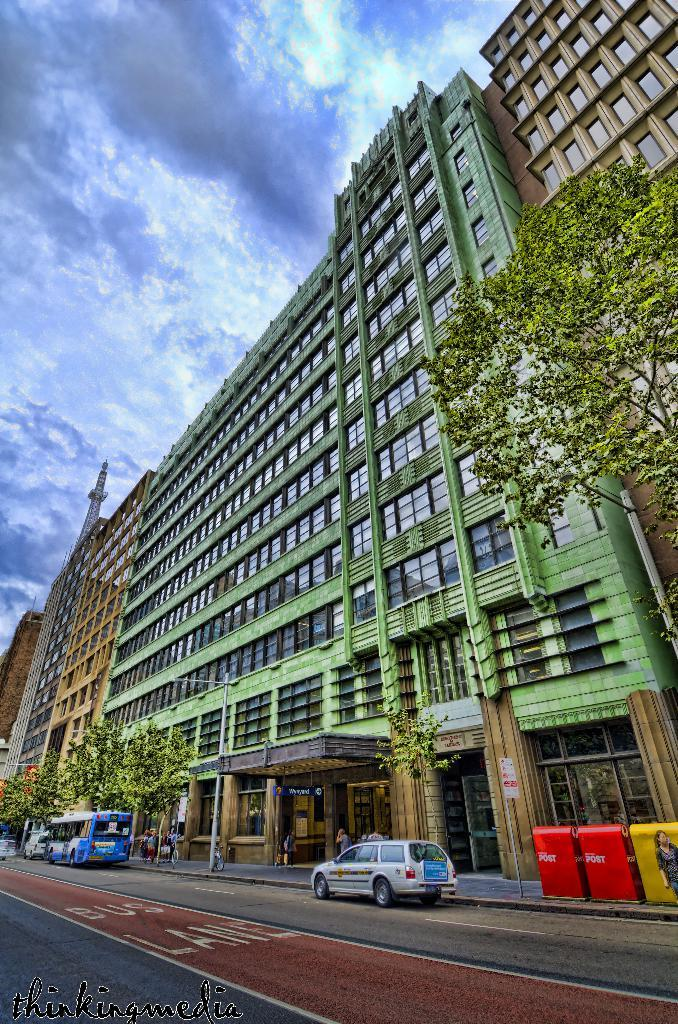What can be seen at the bottom of the image? There are vehicles on the road at the bottom of the image. What is visible in the background of the image? Buildings, glass doors, poles, trees, and hoardings are visible in the background of the image. Where is the tower located in the image? The tower is on the left side of the image. What is visible in the sky in the image? Clouds are visible in the sky. Can you tell me how many stalks of celery are being carried by the cattle in the image? There are no cattle or celery present in the image. What do you believe the people in the image are thinking? The provided facts do not give any information about the thoughts or beliefs of the people in the image. 